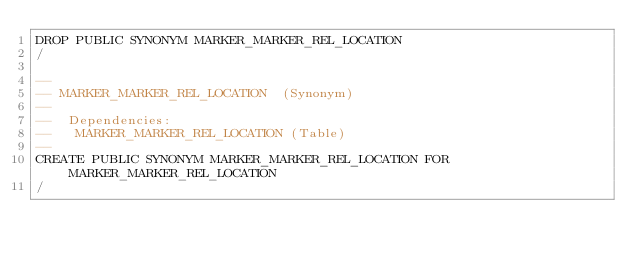Convert code to text. <code><loc_0><loc_0><loc_500><loc_500><_SQL_>DROP PUBLIC SYNONYM MARKER_MARKER_REL_LOCATION
/

--
-- MARKER_MARKER_REL_LOCATION  (Synonym) 
--
--  Dependencies: 
--   MARKER_MARKER_REL_LOCATION (Table)
--
CREATE PUBLIC SYNONYM MARKER_MARKER_REL_LOCATION FOR MARKER_MARKER_REL_LOCATION
/


</code> 